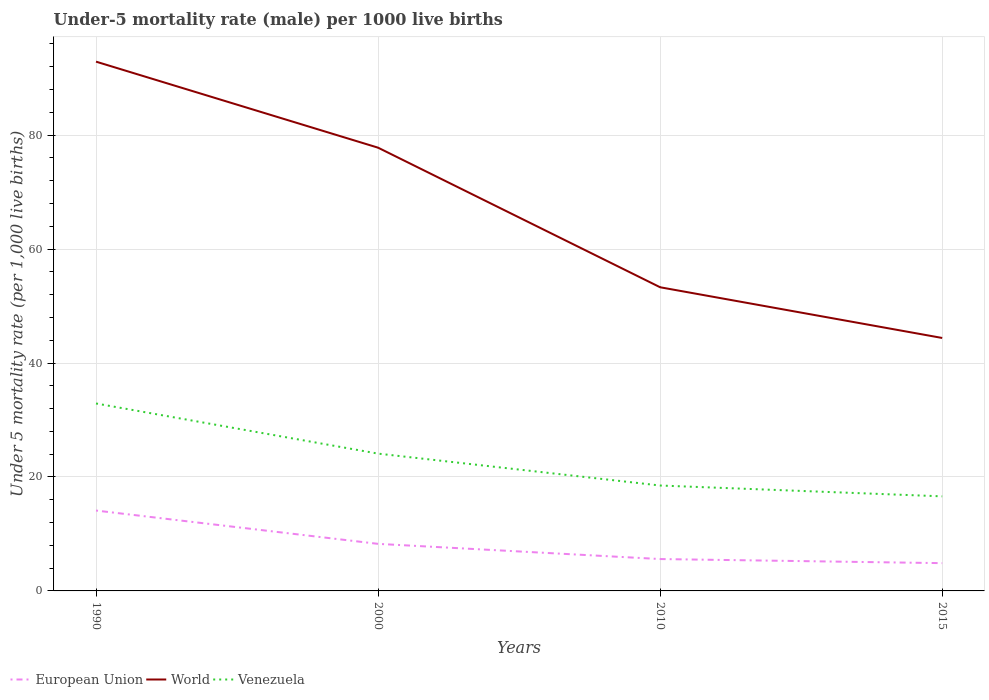Across all years, what is the maximum under-five mortality rate in World?
Keep it short and to the point. 44.4. In which year was the under-five mortality rate in European Union maximum?
Provide a short and direct response. 2015. What is the total under-five mortality rate in World in the graph?
Provide a succinct answer. 48.5. What is the difference between the highest and the second highest under-five mortality rate in World?
Provide a succinct answer. 48.5. How many lines are there?
Give a very brief answer. 3. How many years are there in the graph?
Ensure brevity in your answer.  4. Does the graph contain any zero values?
Your answer should be compact. No. Where does the legend appear in the graph?
Your answer should be very brief. Bottom left. How many legend labels are there?
Offer a very short reply. 3. What is the title of the graph?
Give a very brief answer. Under-5 mortality rate (male) per 1000 live births. Does "Czech Republic" appear as one of the legend labels in the graph?
Your answer should be compact. No. What is the label or title of the Y-axis?
Your response must be concise. Under 5 mortality rate (per 1,0 live births). What is the Under 5 mortality rate (per 1,000 live births) of European Union in 1990?
Ensure brevity in your answer.  14.11. What is the Under 5 mortality rate (per 1,000 live births) in World in 1990?
Keep it short and to the point. 92.9. What is the Under 5 mortality rate (per 1,000 live births) in Venezuela in 1990?
Make the answer very short. 32.9. What is the Under 5 mortality rate (per 1,000 live births) of European Union in 2000?
Your answer should be very brief. 8.26. What is the Under 5 mortality rate (per 1,000 live births) of World in 2000?
Give a very brief answer. 77.8. What is the Under 5 mortality rate (per 1,000 live births) in Venezuela in 2000?
Give a very brief answer. 24.1. What is the Under 5 mortality rate (per 1,000 live births) in European Union in 2010?
Your response must be concise. 5.6. What is the Under 5 mortality rate (per 1,000 live births) of World in 2010?
Offer a very short reply. 53.3. What is the Under 5 mortality rate (per 1,000 live births) in Venezuela in 2010?
Make the answer very short. 18.5. What is the Under 5 mortality rate (per 1,000 live births) of European Union in 2015?
Make the answer very short. 4.88. What is the Under 5 mortality rate (per 1,000 live births) of World in 2015?
Your answer should be compact. 44.4. What is the Under 5 mortality rate (per 1,000 live births) in Venezuela in 2015?
Provide a short and direct response. 16.6. Across all years, what is the maximum Under 5 mortality rate (per 1,000 live births) in European Union?
Offer a terse response. 14.11. Across all years, what is the maximum Under 5 mortality rate (per 1,000 live births) of World?
Your answer should be compact. 92.9. Across all years, what is the maximum Under 5 mortality rate (per 1,000 live births) of Venezuela?
Make the answer very short. 32.9. Across all years, what is the minimum Under 5 mortality rate (per 1,000 live births) of European Union?
Your answer should be compact. 4.88. Across all years, what is the minimum Under 5 mortality rate (per 1,000 live births) of World?
Your response must be concise. 44.4. Across all years, what is the minimum Under 5 mortality rate (per 1,000 live births) of Venezuela?
Make the answer very short. 16.6. What is the total Under 5 mortality rate (per 1,000 live births) of European Union in the graph?
Provide a succinct answer. 32.84. What is the total Under 5 mortality rate (per 1,000 live births) in World in the graph?
Your answer should be very brief. 268.4. What is the total Under 5 mortality rate (per 1,000 live births) in Venezuela in the graph?
Provide a succinct answer. 92.1. What is the difference between the Under 5 mortality rate (per 1,000 live births) of European Union in 1990 and that in 2000?
Keep it short and to the point. 5.85. What is the difference between the Under 5 mortality rate (per 1,000 live births) in European Union in 1990 and that in 2010?
Give a very brief answer. 8.51. What is the difference between the Under 5 mortality rate (per 1,000 live births) of World in 1990 and that in 2010?
Your response must be concise. 39.6. What is the difference between the Under 5 mortality rate (per 1,000 live births) of European Union in 1990 and that in 2015?
Your answer should be compact. 9.23. What is the difference between the Under 5 mortality rate (per 1,000 live births) in World in 1990 and that in 2015?
Your answer should be compact. 48.5. What is the difference between the Under 5 mortality rate (per 1,000 live births) of European Union in 2000 and that in 2010?
Offer a very short reply. 2.66. What is the difference between the Under 5 mortality rate (per 1,000 live births) of European Union in 2000 and that in 2015?
Your answer should be compact. 3.38. What is the difference between the Under 5 mortality rate (per 1,000 live births) in World in 2000 and that in 2015?
Provide a short and direct response. 33.4. What is the difference between the Under 5 mortality rate (per 1,000 live births) of European Union in 2010 and that in 2015?
Your answer should be compact. 0.72. What is the difference between the Under 5 mortality rate (per 1,000 live births) of Venezuela in 2010 and that in 2015?
Ensure brevity in your answer.  1.9. What is the difference between the Under 5 mortality rate (per 1,000 live births) of European Union in 1990 and the Under 5 mortality rate (per 1,000 live births) of World in 2000?
Ensure brevity in your answer.  -63.69. What is the difference between the Under 5 mortality rate (per 1,000 live births) in European Union in 1990 and the Under 5 mortality rate (per 1,000 live births) in Venezuela in 2000?
Provide a short and direct response. -9.99. What is the difference between the Under 5 mortality rate (per 1,000 live births) of World in 1990 and the Under 5 mortality rate (per 1,000 live births) of Venezuela in 2000?
Provide a succinct answer. 68.8. What is the difference between the Under 5 mortality rate (per 1,000 live births) of European Union in 1990 and the Under 5 mortality rate (per 1,000 live births) of World in 2010?
Keep it short and to the point. -39.19. What is the difference between the Under 5 mortality rate (per 1,000 live births) of European Union in 1990 and the Under 5 mortality rate (per 1,000 live births) of Venezuela in 2010?
Your response must be concise. -4.39. What is the difference between the Under 5 mortality rate (per 1,000 live births) of World in 1990 and the Under 5 mortality rate (per 1,000 live births) of Venezuela in 2010?
Your response must be concise. 74.4. What is the difference between the Under 5 mortality rate (per 1,000 live births) in European Union in 1990 and the Under 5 mortality rate (per 1,000 live births) in World in 2015?
Make the answer very short. -30.29. What is the difference between the Under 5 mortality rate (per 1,000 live births) in European Union in 1990 and the Under 5 mortality rate (per 1,000 live births) in Venezuela in 2015?
Your answer should be compact. -2.49. What is the difference between the Under 5 mortality rate (per 1,000 live births) of World in 1990 and the Under 5 mortality rate (per 1,000 live births) of Venezuela in 2015?
Provide a short and direct response. 76.3. What is the difference between the Under 5 mortality rate (per 1,000 live births) of European Union in 2000 and the Under 5 mortality rate (per 1,000 live births) of World in 2010?
Make the answer very short. -45.04. What is the difference between the Under 5 mortality rate (per 1,000 live births) in European Union in 2000 and the Under 5 mortality rate (per 1,000 live births) in Venezuela in 2010?
Keep it short and to the point. -10.24. What is the difference between the Under 5 mortality rate (per 1,000 live births) of World in 2000 and the Under 5 mortality rate (per 1,000 live births) of Venezuela in 2010?
Your answer should be very brief. 59.3. What is the difference between the Under 5 mortality rate (per 1,000 live births) in European Union in 2000 and the Under 5 mortality rate (per 1,000 live births) in World in 2015?
Your answer should be very brief. -36.14. What is the difference between the Under 5 mortality rate (per 1,000 live births) in European Union in 2000 and the Under 5 mortality rate (per 1,000 live births) in Venezuela in 2015?
Provide a short and direct response. -8.34. What is the difference between the Under 5 mortality rate (per 1,000 live births) of World in 2000 and the Under 5 mortality rate (per 1,000 live births) of Venezuela in 2015?
Keep it short and to the point. 61.2. What is the difference between the Under 5 mortality rate (per 1,000 live births) in European Union in 2010 and the Under 5 mortality rate (per 1,000 live births) in World in 2015?
Ensure brevity in your answer.  -38.8. What is the difference between the Under 5 mortality rate (per 1,000 live births) in European Union in 2010 and the Under 5 mortality rate (per 1,000 live births) in Venezuela in 2015?
Provide a succinct answer. -11. What is the difference between the Under 5 mortality rate (per 1,000 live births) in World in 2010 and the Under 5 mortality rate (per 1,000 live births) in Venezuela in 2015?
Provide a succinct answer. 36.7. What is the average Under 5 mortality rate (per 1,000 live births) in European Union per year?
Make the answer very short. 8.21. What is the average Under 5 mortality rate (per 1,000 live births) in World per year?
Offer a terse response. 67.1. What is the average Under 5 mortality rate (per 1,000 live births) of Venezuela per year?
Keep it short and to the point. 23.02. In the year 1990, what is the difference between the Under 5 mortality rate (per 1,000 live births) in European Union and Under 5 mortality rate (per 1,000 live births) in World?
Give a very brief answer. -78.79. In the year 1990, what is the difference between the Under 5 mortality rate (per 1,000 live births) in European Union and Under 5 mortality rate (per 1,000 live births) in Venezuela?
Your response must be concise. -18.79. In the year 2000, what is the difference between the Under 5 mortality rate (per 1,000 live births) of European Union and Under 5 mortality rate (per 1,000 live births) of World?
Provide a short and direct response. -69.54. In the year 2000, what is the difference between the Under 5 mortality rate (per 1,000 live births) of European Union and Under 5 mortality rate (per 1,000 live births) of Venezuela?
Provide a succinct answer. -15.84. In the year 2000, what is the difference between the Under 5 mortality rate (per 1,000 live births) of World and Under 5 mortality rate (per 1,000 live births) of Venezuela?
Make the answer very short. 53.7. In the year 2010, what is the difference between the Under 5 mortality rate (per 1,000 live births) of European Union and Under 5 mortality rate (per 1,000 live births) of World?
Your answer should be very brief. -47.7. In the year 2010, what is the difference between the Under 5 mortality rate (per 1,000 live births) in European Union and Under 5 mortality rate (per 1,000 live births) in Venezuela?
Your answer should be very brief. -12.9. In the year 2010, what is the difference between the Under 5 mortality rate (per 1,000 live births) of World and Under 5 mortality rate (per 1,000 live births) of Venezuela?
Offer a terse response. 34.8. In the year 2015, what is the difference between the Under 5 mortality rate (per 1,000 live births) of European Union and Under 5 mortality rate (per 1,000 live births) of World?
Provide a succinct answer. -39.52. In the year 2015, what is the difference between the Under 5 mortality rate (per 1,000 live births) in European Union and Under 5 mortality rate (per 1,000 live births) in Venezuela?
Your response must be concise. -11.72. In the year 2015, what is the difference between the Under 5 mortality rate (per 1,000 live births) of World and Under 5 mortality rate (per 1,000 live births) of Venezuela?
Offer a terse response. 27.8. What is the ratio of the Under 5 mortality rate (per 1,000 live births) of European Union in 1990 to that in 2000?
Offer a terse response. 1.71. What is the ratio of the Under 5 mortality rate (per 1,000 live births) of World in 1990 to that in 2000?
Your answer should be very brief. 1.19. What is the ratio of the Under 5 mortality rate (per 1,000 live births) of Venezuela in 1990 to that in 2000?
Your answer should be compact. 1.37. What is the ratio of the Under 5 mortality rate (per 1,000 live births) in European Union in 1990 to that in 2010?
Your answer should be very brief. 2.52. What is the ratio of the Under 5 mortality rate (per 1,000 live births) of World in 1990 to that in 2010?
Your answer should be compact. 1.74. What is the ratio of the Under 5 mortality rate (per 1,000 live births) of Venezuela in 1990 to that in 2010?
Offer a very short reply. 1.78. What is the ratio of the Under 5 mortality rate (per 1,000 live births) of European Union in 1990 to that in 2015?
Ensure brevity in your answer.  2.89. What is the ratio of the Under 5 mortality rate (per 1,000 live births) in World in 1990 to that in 2015?
Your response must be concise. 2.09. What is the ratio of the Under 5 mortality rate (per 1,000 live births) in Venezuela in 1990 to that in 2015?
Ensure brevity in your answer.  1.98. What is the ratio of the Under 5 mortality rate (per 1,000 live births) of European Union in 2000 to that in 2010?
Provide a succinct answer. 1.48. What is the ratio of the Under 5 mortality rate (per 1,000 live births) in World in 2000 to that in 2010?
Make the answer very short. 1.46. What is the ratio of the Under 5 mortality rate (per 1,000 live births) of Venezuela in 2000 to that in 2010?
Provide a short and direct response. 1.3. What is the ratio of the Under 5 mortality rate (per 1,000 live births) in European Union in 2000 to that in 2015?
Your response must be concise. 1.69. What is the ratio of the Under 5 mortality rate (per 1,000 live births) of World in 2000 to that in 2015?
Ensure brevity in your answer.  1.75. What is the ratio of the Under 5 mortality rate (per 1,000 live births) in Venezuela in 2000 to that in 2015?
Make the answer very short. 1.45. What is the ratio of the Under 5 mortality rate (per 1,000 live births) in European Union in 2010 to that in 2015?
Your answer should be compact. 1.15. What is the ratio of the Under 5 mortality rate (per 1,000 live births) in World in 2010 to that in 2015?
Your answer should be very brief. 1.2. What is the ratio of the Under 5 mortality rate (per 1,000 live births) of Venezuela in 2010 to that in 2015?
Keep it short and to the point. 1.11. What is the difference between the highest and the second highest Under 5 mortality rate (per 1,000 live births) in European Union?
Give a very brief answer. 5.85. What is the difference between the highest and the second highest Under 5 mortality rate (per 1,000 live births) of World?
Offer a very short reply. 15.1. What is the difference between the highest and the second highest Under 5 mortality rate (per 1,000 live births) of Venezuela?
Your answer should be very brief. 8.8. What is the difference between the highest and the lowest Under 5 mortality rate (per 1,000 live births) in European Union?
Make the answer very short. 9.23. What is the difference between the highest and the lowest Under 5 mortality rate (per 1,000 live births) in World?
Your response must be concise. 48.5. What is the difference between the highest and the lowest Under 5 mortality rate (per 1,000 live births) of Venezuela?
Give a very brief answer. 16.3. 